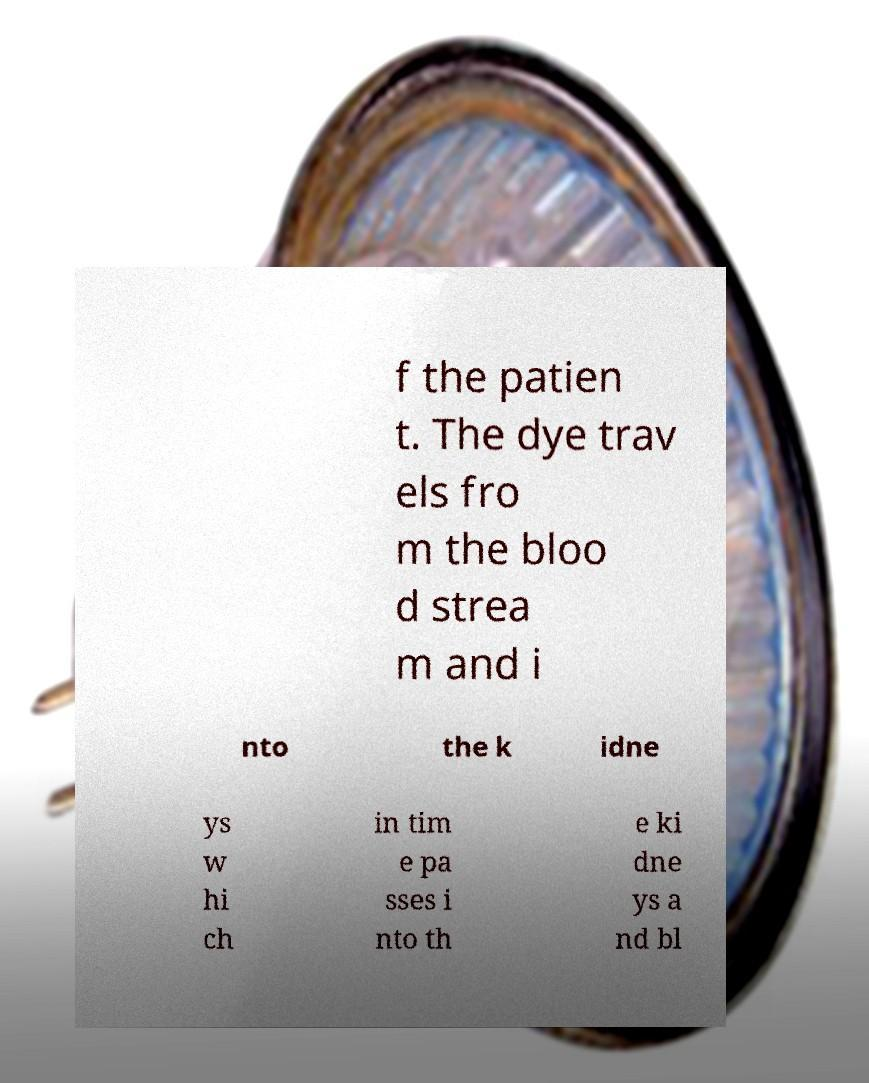For documentation purposes, I need the text within this image transcribed. Could you provide that? f the patien t. The dye trav els fro m the bloo d strea m and i nto the k idne ys w hi ch in tim e pa sses i nto th e ki dne ys a nd bl 